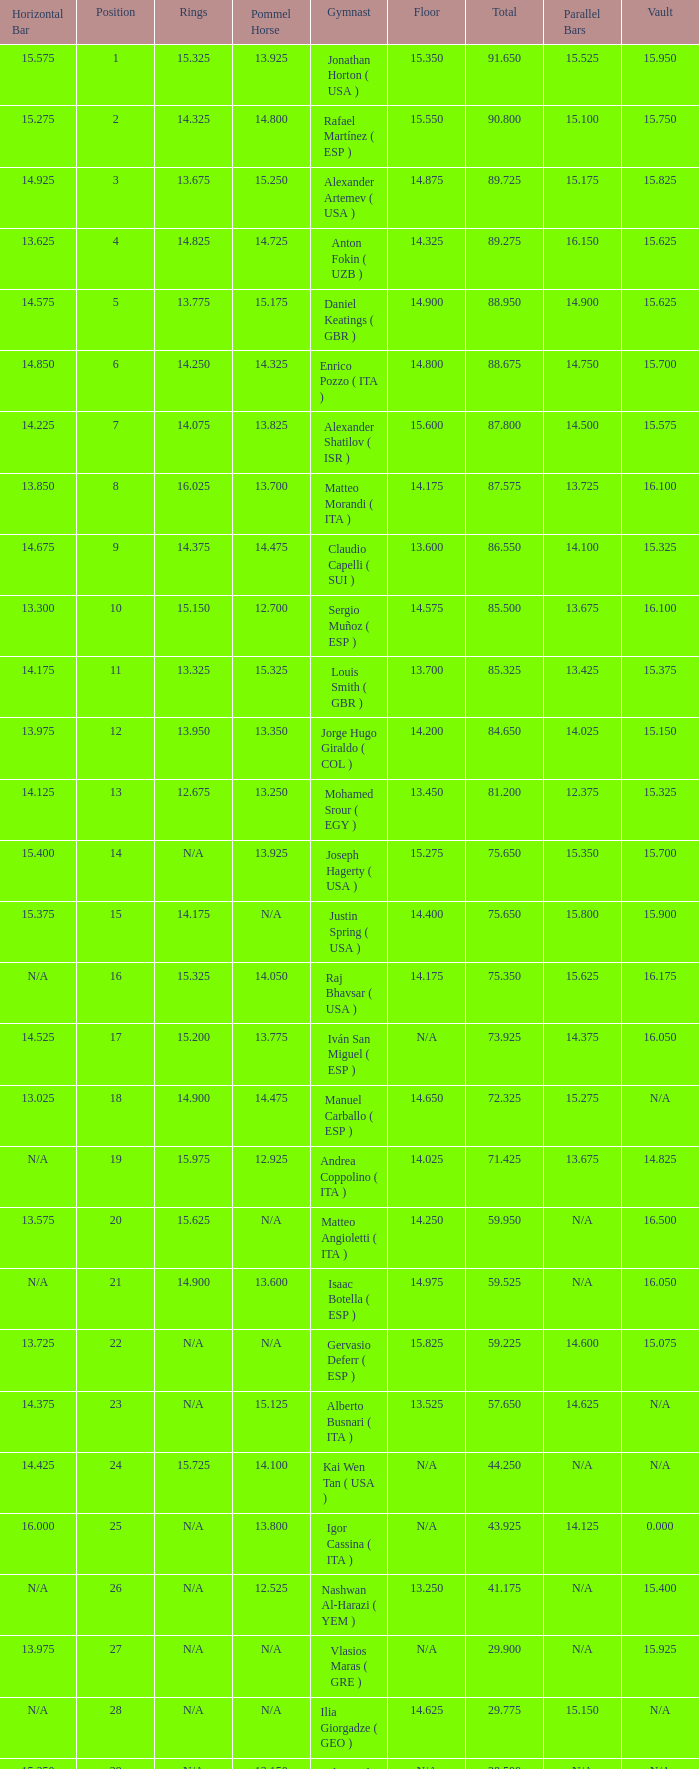If the floor number is 14.200, what is the number for the parallel bars? 14.025. 